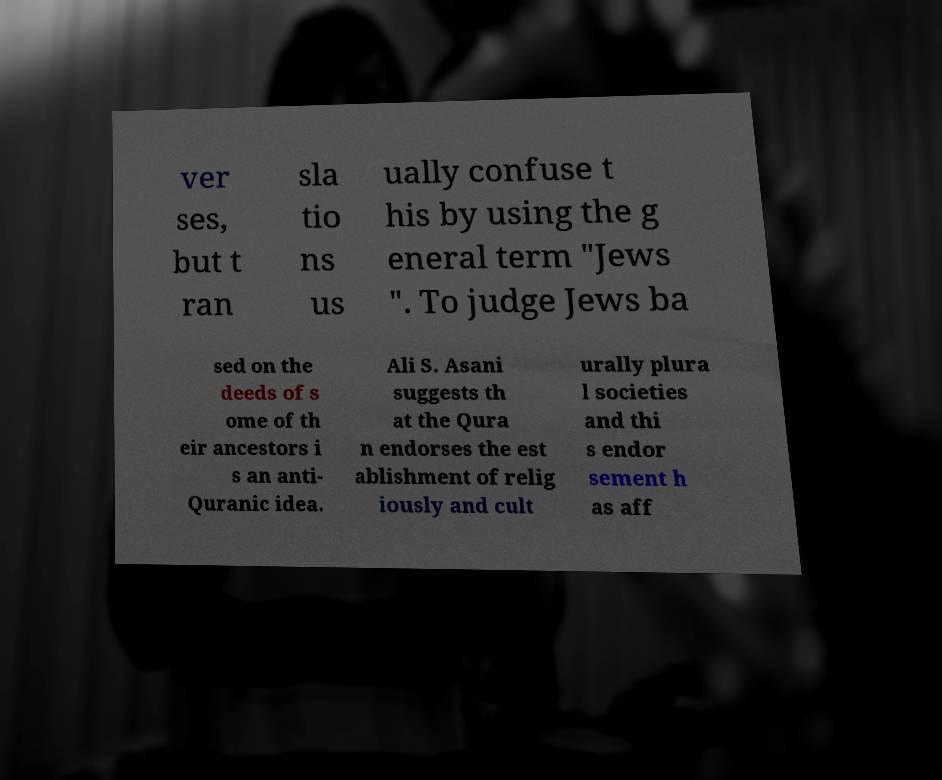What messages or text are displayed in this image? I need them in a readable, typed format. ver ses, but t ran sla tio ns us ually confuse t his by using the g eneral term "Jews ". To judge Jews ba sed on the deeds of s ome of th eir ancestors i s an anti- Quranic idea. Ali S. Asani suggests th at the Qura n endorses the est ablishment of relig iously and cult urally plura l societies and thi s endor sement h as aff 